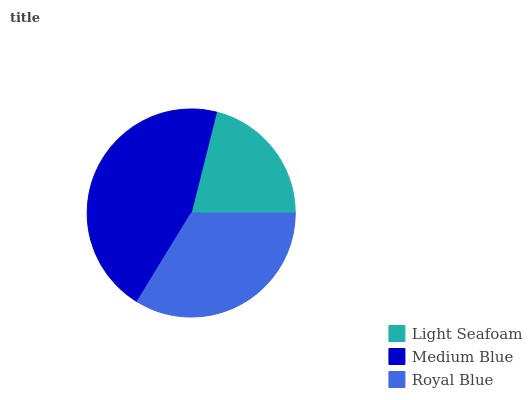Is Light Seafoam the minimum?
Answer yes or no. Yes. Is Medium Blue the maximum?
Answer yes or no. Yes. Is Royal Blue the minimum?
Answer yes or no. No. Is Royal Blue the maximum?
Answer yes or no. No. Is Medium Blue greater than Royal Blue?
Answer yes or no. Yes. Is Royal Blue less than Medium Blue?
Answer yes or no. Yes. Is Royal Blue greater than Medium Blue?
Answer yes or no. No. Is Medium Blue less than Royal Blue?
Answer yes or no. No. Is Royal Blue the high median?
Answer yes or no. Yes. Is Royal Blue the low median?
Answer yes or no. Yes. Is Medium Blue the high median?
Answer yes or no. No. Is Medium Blue the low median?
Answer yes or no. No. 